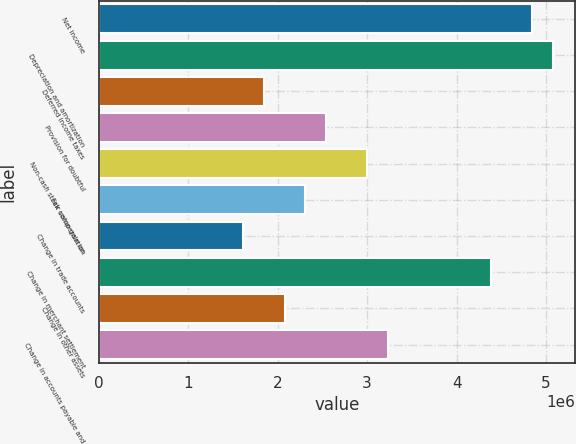Convert chart to OTSL. <chart><loc_0><loc_0><loc_500><loc_500><bar_chart><fcel>Net income<fcel>Depreciation and amortization<fcel>Deferred income taxes<fcel>Provision for doubtful<fcel>Non-cash stock compensation<fcel>Fair value gain on<fcel>Change in trade accounts<fcel>Change in merchant settlement<fcel>Change in other assets<fcel>Change in accounts payable and<nl><fcel>4.8415e+06<fcel>5.07173e+06<fcel>1.84855e+06<fcel>2.53923e+06<fcel>2.99968e+06<fcel>2.309e+06<fcel>1.61832e+06<fcel>4.38104e+06<fcel>2.07877e+06<fcel>3.22991e+06<nl></chart> 